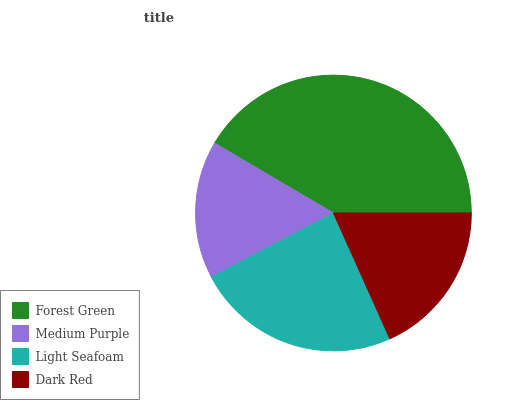Is Medium Purple the minimum?
Answer yes or no. Yes. Is Forest Green the maximum?
Answer yes or no. Yes. Is Light Seafoam the minimum?
Answer yes or no. No. Is Light Seafoam the maximum?
Answer yes or no. No. Is Light Seafoam greater than Medium Purple?
Answer yes or no. Yes. Is Medium Purple less than Light Seafoam?
Answer yes or no. Yes. Is Medium Purple greater than Light Seafoam?
Answer yes or no. No. Is Light Seafoam less than Medium Purple?
Answer yes or no. No. Is Light Seafoam the high median?
Answer yes or no. Yes. Is Dark Red the low median?
Answer yes or no. Yes. Is Medium Purple the high median?
Answer yes or no. No. Is Medium Purple the low median?
Answer yes or no. No. 